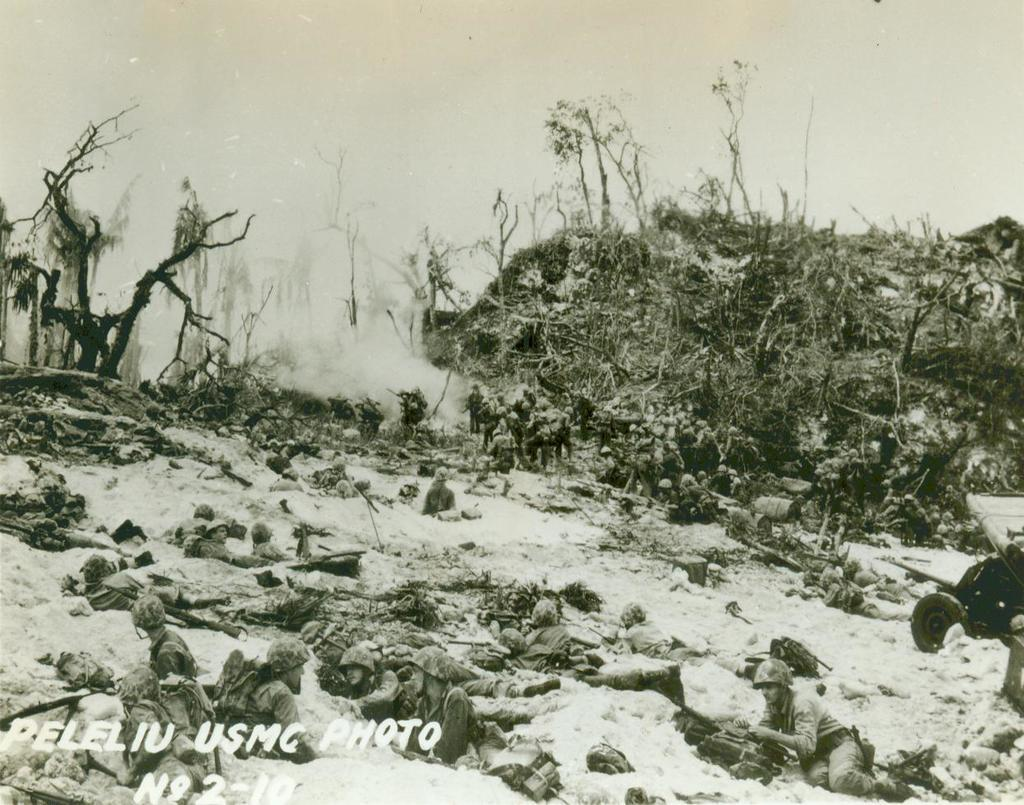What is the color scheme of the image? The image is black and white. Who or what can be seen in the image? There are people in the image. Is there any text present in the image? Yes, there is text in the bottom left of the image. What type of natural environment is visible in the background of the image? The background of the image includes trees, and the sky is visible as well. What flavor of sink is depicted in the image? There is no sink present in the image, and therefore no flavor can be determined. What type of amusement can be seen in the image? There is no amusement depicted in the image; it primarily features people and text. 